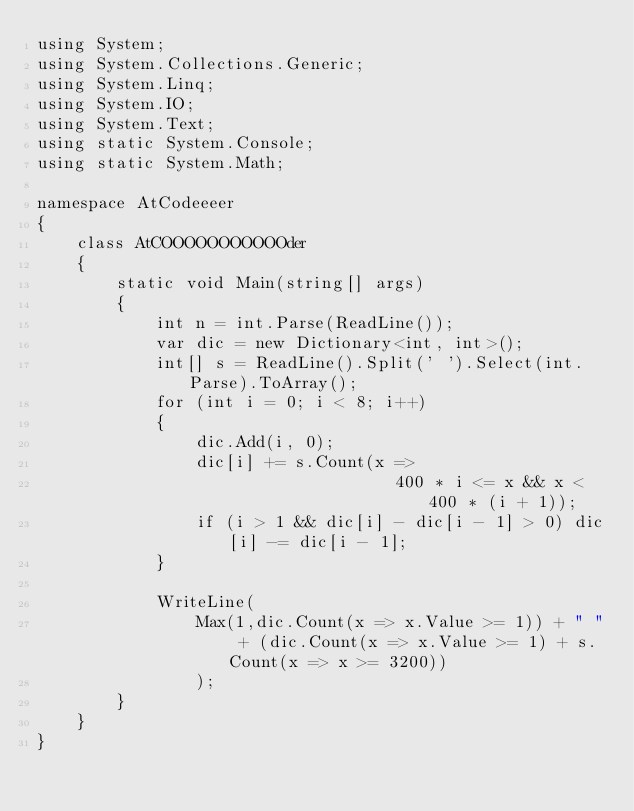<code> <loc_0><loc_0><loc_500><loc_500><_C#_>using System;
using System.Collections.Generic;
using System.Linq;
using System.IO;
using System.Text;
using static System.Console;
using static System.Math;

namespace AtCodeeeer
{
    class AtCOOOOOOOOOOOder
    {
        static void Main(string[] args)
        {
            int n = int.Parse(ReadLine());
            var dic = new Dictionary<int, int>();
            int[] s = ReadLine().Split(' ').Select(int.Parse).ToArray();
            for (int i = 0; i < 8; i++)
            {
                dic.Add(i, 0);
                dic[i] += s.Count(x =>
                                    400 * i <= x && x < 400 * (i + 1));
                if (i > 1 && dic[i] - dic[i - 1] > 0) dic[i] -= dic[i - 1];
            }
           
            WriteLine(
                Max(1,dic.Count(x => x.Value >= 1)) + " " + (dic.Count(x => x.Value >= 1) + s.Count(x => x >= 3200))
                );
        }
    }
}</code> 